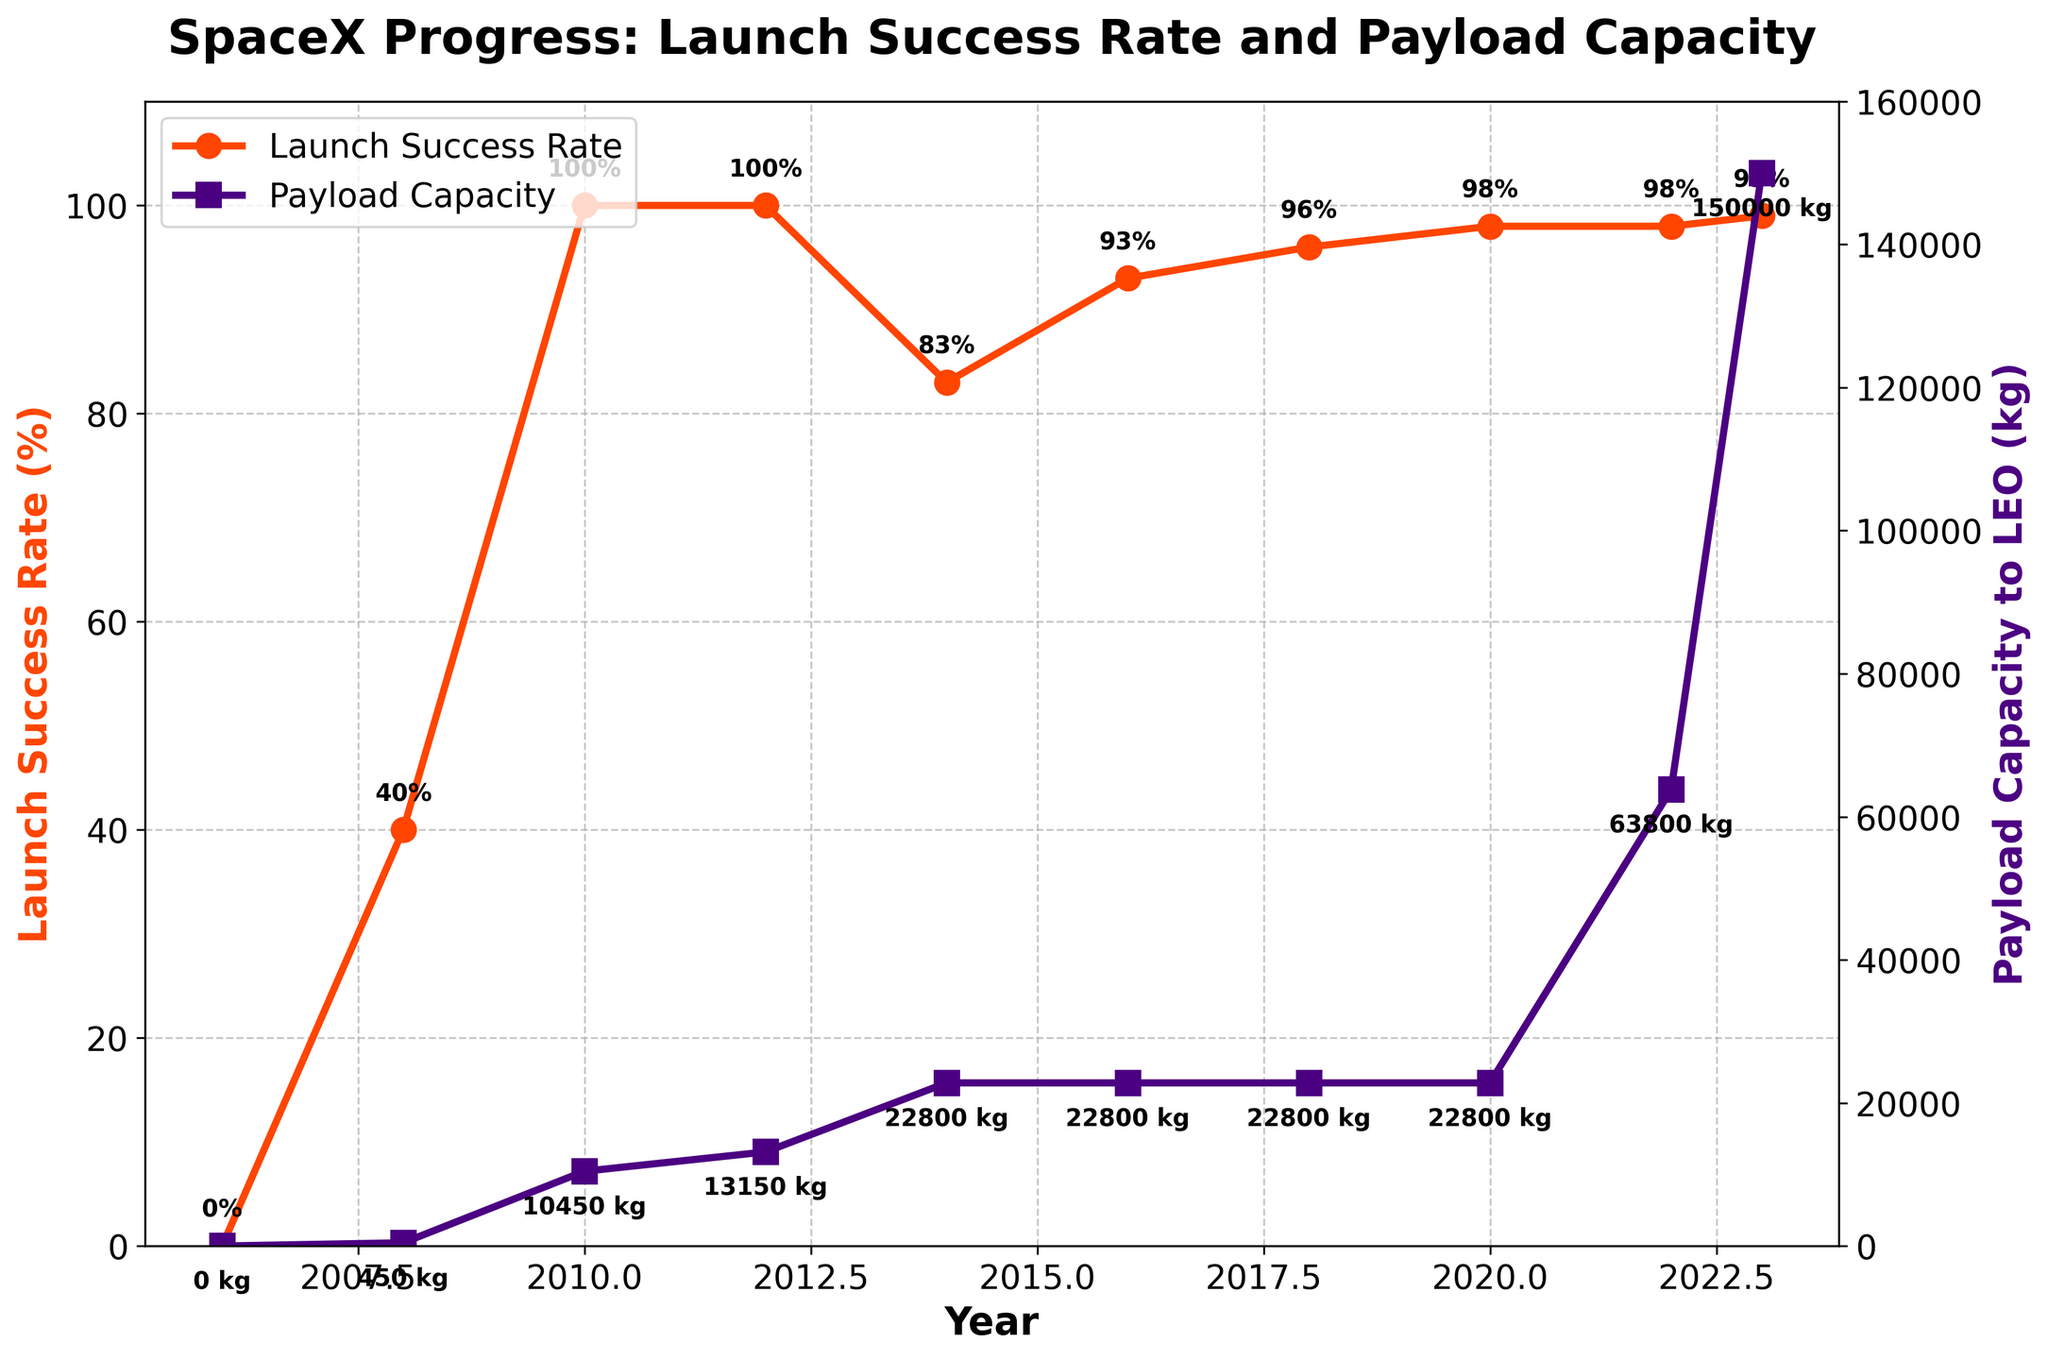What's the increase in the payload capacity from 2018 to 2023? To find the increase, subtract the payload capacity in 2018 from the capacity in 2023. 150,000 kg (2023) - 22,800 kg (2018) = 127,200 kg
Answer: 127,200 kg In which year did SpaceX achieve its first 100% launch success rate? Look for the first year where the Launch Success Rate (%) reaches 100% on the chart. The year is 2010.
Answer: 2010 How did the payload capacity change between 2008 and 2010? Subtract the payload capacity in 2008 from the capacity in 2010. 10,450 kg (2010) - 450 kg (2008) = 10,000 kg
Answer: 10,000 kg Is there any year where both the Launch Success Rate and Payload Capacity increased compared to the previous year? Compare successive years to identify if both metrics increased. The change happens between 2008 and 2010.
Answer: 2010 Which year has the highest launch success rate, and what is the rate? Identify the highest point on the Launch Success Rate line. The year is 2023 with a rate of 99%.
Answer: 2023, 99% When was the Payload Capacity to LEO tripled compared to its 2014 value? The payload capacity in 2014 was 22,800 kg. Tripling it gives 68,400 kg. The closest higher value is 63,800 kg in 2022.
Answer: 2022 Did the Launch Success Rate ever decrease after 2012? Check the Launch Success Rate line post-2012 for any drops. The rate decreases in 2014 to 83%.
Answer: Yes, in 2014 Compare the payload capacity in 2014 with 2023. Which year has a higher payload, and by how much? Subtract the 2014 payload capacity from the 2023 capacity. 150,000 kg (2023) - 22,800 kg (2014) = 127,200 kg higher in 2023.
Answer: 2023 by 127,200 kg Which visual change is more pronounced after 2014: increase in Launch Success Rate or Payload Capacity? Look at the trend lines after 2014 for both metrics. The Payload Capacity shows a more pronounced increase in 2022 and 2023.
Answer: Payload Capacity What denotes the 2010 Launch Success Rate and 2018 Payload Capacity on the chart? The 2010 Launch Success Rate is marked with an annotation of "100%" and the 2018 Payload Capacity with "22,800 kg".
Answer: "100%" and "22,800 kg" 